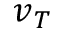<formula> <loc_0><loc_0><loc_500><loc_500>v _ { T }</formula> 